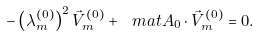Convert formula to latex. <formula><loc_0><loc_0><loc_500><loc_500>- \left ( \lambda ^ { ( 0 ) } _ { m } \right ) ^ { 2 } \vec { V } ^ { ( 0 ) } _ { m } + \ m a t { A } _ { 0 } \cdot \vec { V } ^ { ( 0 ) } _ { m } = 0 .</formula> 